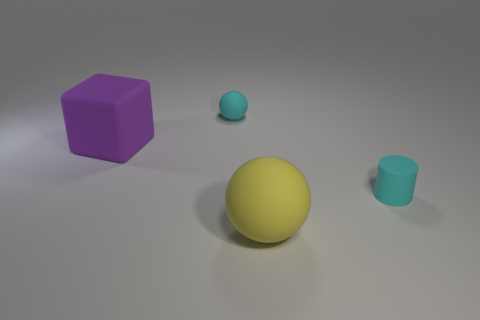Add 2 tiny yellow things. How many objects exist? 6 Subtract all cylinders. How many objects are left? 3 Add 2 purple objects. How many purple objects exist? 3 Subtract 0 brown cylinders. How many objects are left? 4 Subtract all brown cylinders. Subtract all tiny cyan objects. How many objects are left? 2 Add 1 large yellow objects. How many large yellow objects are left? 2 